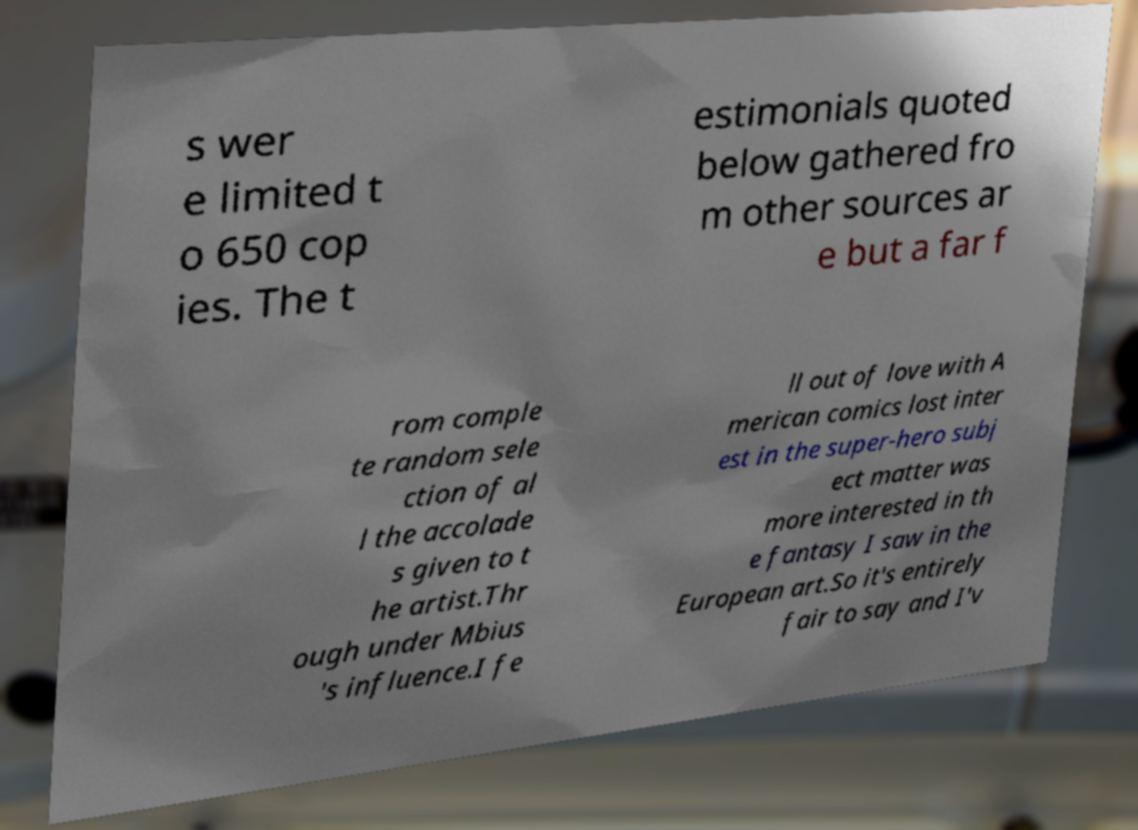Please identify and transcribe the text found in this image. s wer e limited t o 650 cop ies. The t estimonials quoted below gathered fro m other sources ar e but a far f rom comple te random sele ction of al l the accolade s given to t he artist.Thr ough under Mbius 's influence.I fe ll out of love with A merican comics lost inter est in the super-hero subj ect matter was more interested in th e fantasy I saw in the European art.So it's entirely fair to say and I'v 